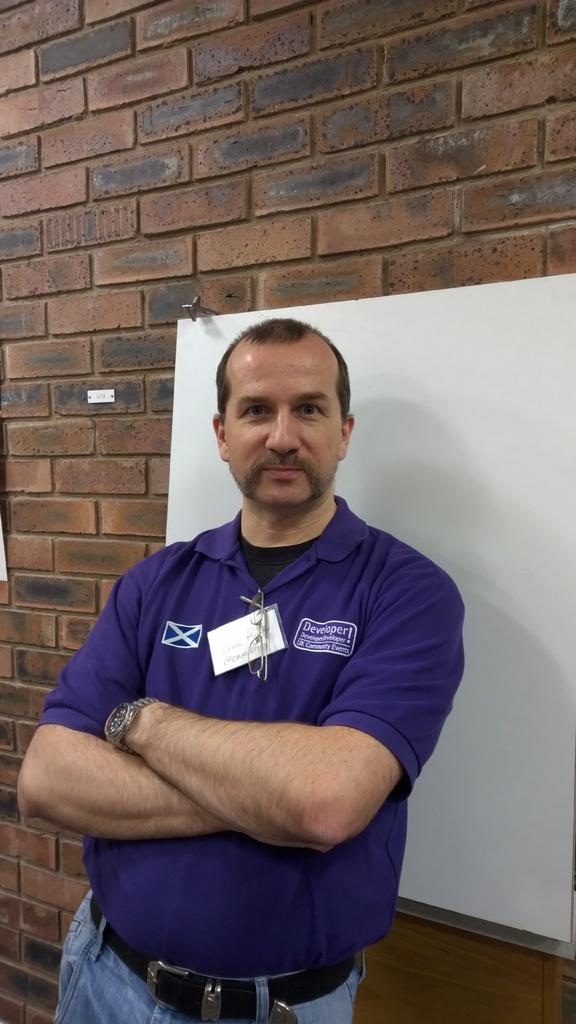Who is present in the image? There is a man in the image. What is the man doing in the image? The man is standing in the image. What expression does the man have in the image? The man is smiling in the image. What can be seen in the background of the image? There is a board and a wall in the background of the image. What type of effect does the deer have on the earth in the image? There is no deer present in the image, so it is not possible to determine any effect on the earth. 